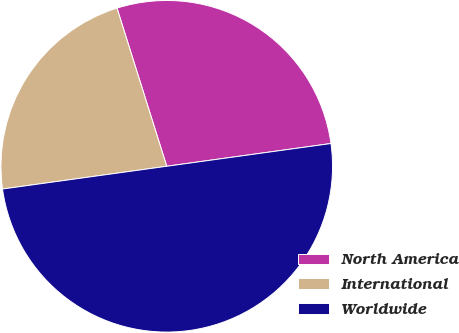<chart> <loc_0><loc_0><loc_500><loc_500><pie_chart><fcel>North America<fcel>International<fcel>Worldwide<nl><fcel>27.66%<fcel>22.34%<fcel>50.0%<nl></chart> 